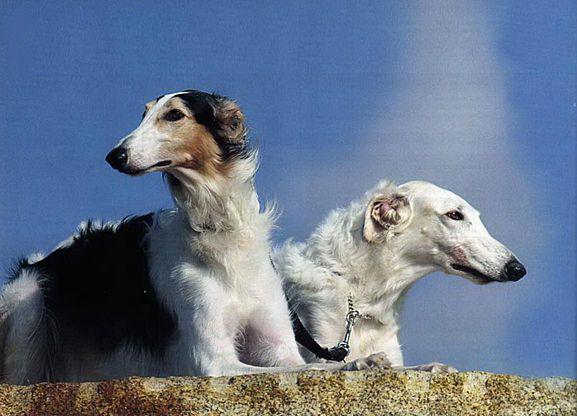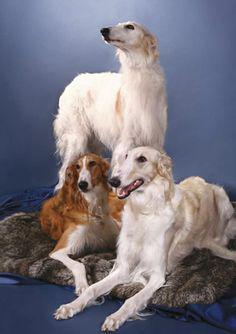The first image is the image on the left, the second image is the image on the right. For the images shown, is this caption "One of the two dogs in the image on the left is standing while the other is lying down." true? Answer yes or no. No. The first image is the image on the left, the second image is the image on the right. Considering the images on both sides, is "One image shows a trio of dogs, with two reclining next to a standing dog." valid? Answer yes or no. Yes. 